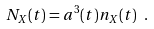<formula> <loc_0><loc_0><loc_500><loc_500>N _ { X } ( t ) = a ^ { 3 } ( t ) n _ { X } ( t ) \ .</formula> 